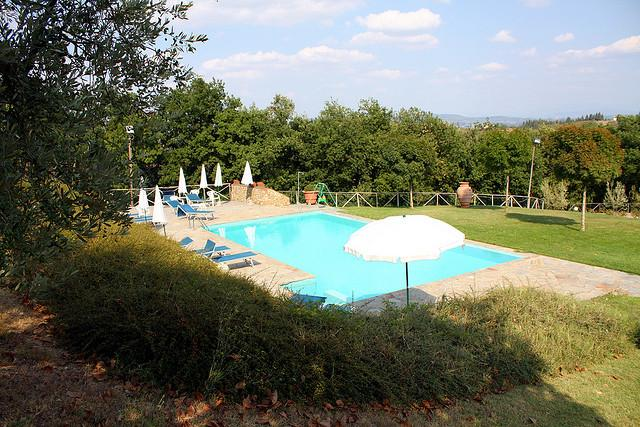Where is this pool located at? Please explain your reasoning. backyard. The pool is located in the backyard of a house in a residential area. 